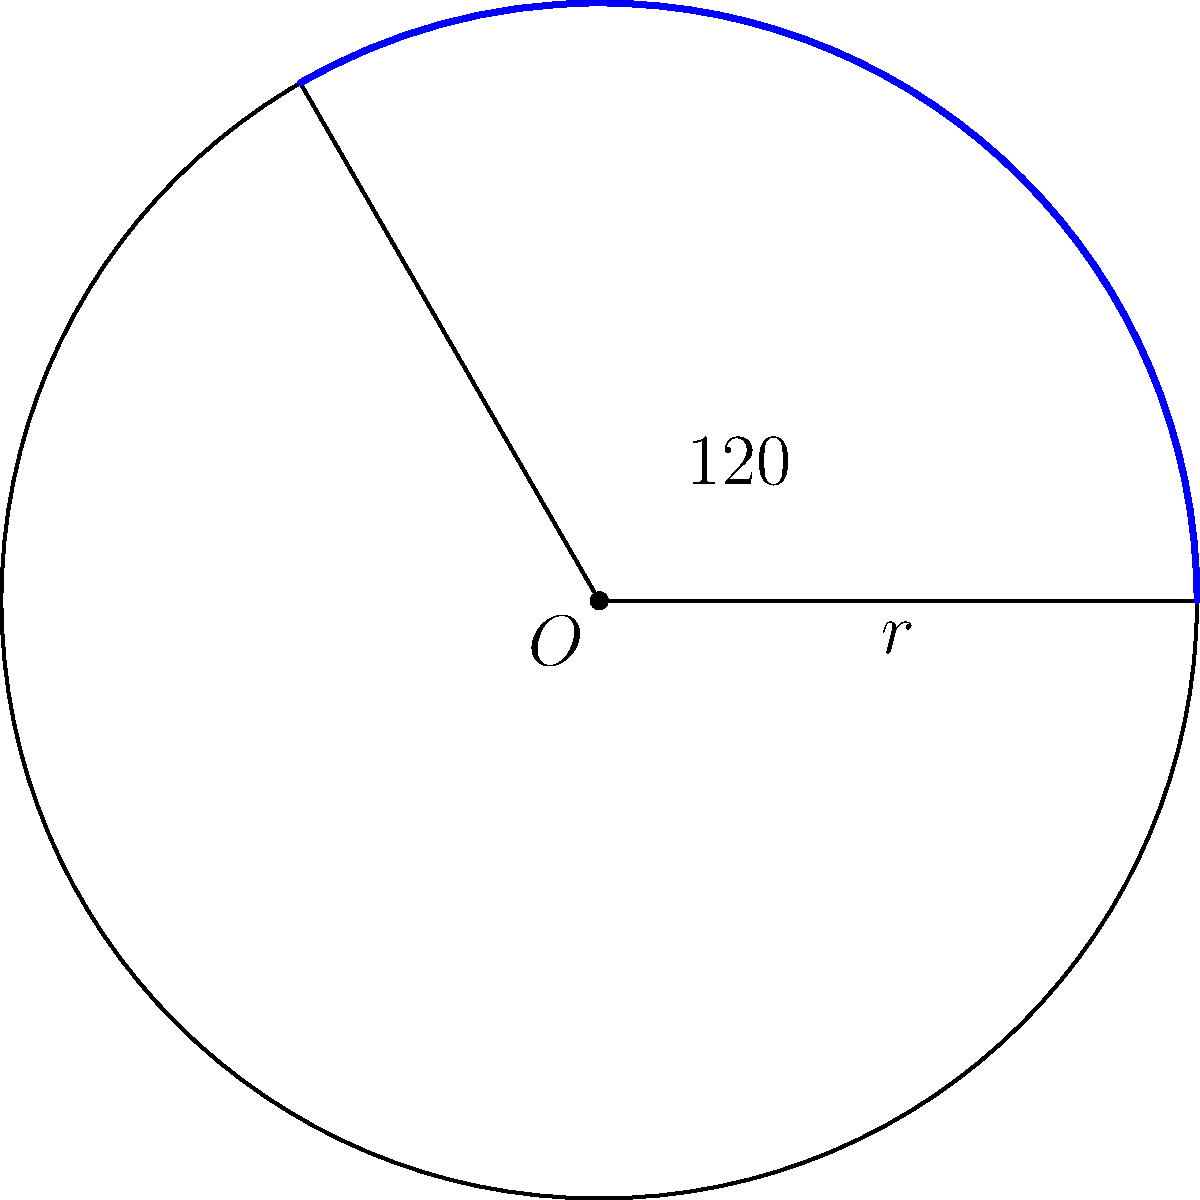In a circular laboratory flask, a chemist is studying the properties of a new compound along its curved surface. The flask has a radius of 15 cm, and the area of interest spans a central angle of 120°. Calculate the length of the arc that represents this area of interest on the flask's surface. To solve this problem, we'll use the formula for arc length:

$s = r\theta$

Where:
$s$ = arc length
$r$ = radius of the circle
$\theta$ = central angle in radians

Step 1: Convert the central angle from degrees to radians.
$\theta = 120° \times \frac{\pi}{180°} = \frac{2\pi}{3}$ radians

Step 2: Apply the arc length formula.
$s = r\theta$
$s = 15 \times \frac{2\pi}{3}$

Step 3: Simplify the expression.
$s = 10\pi$ cm

Therefore, the length of the arc representing the area of interest on the flask's surface is $10\pi$ cm.
Answer: $10\pi$ cm 